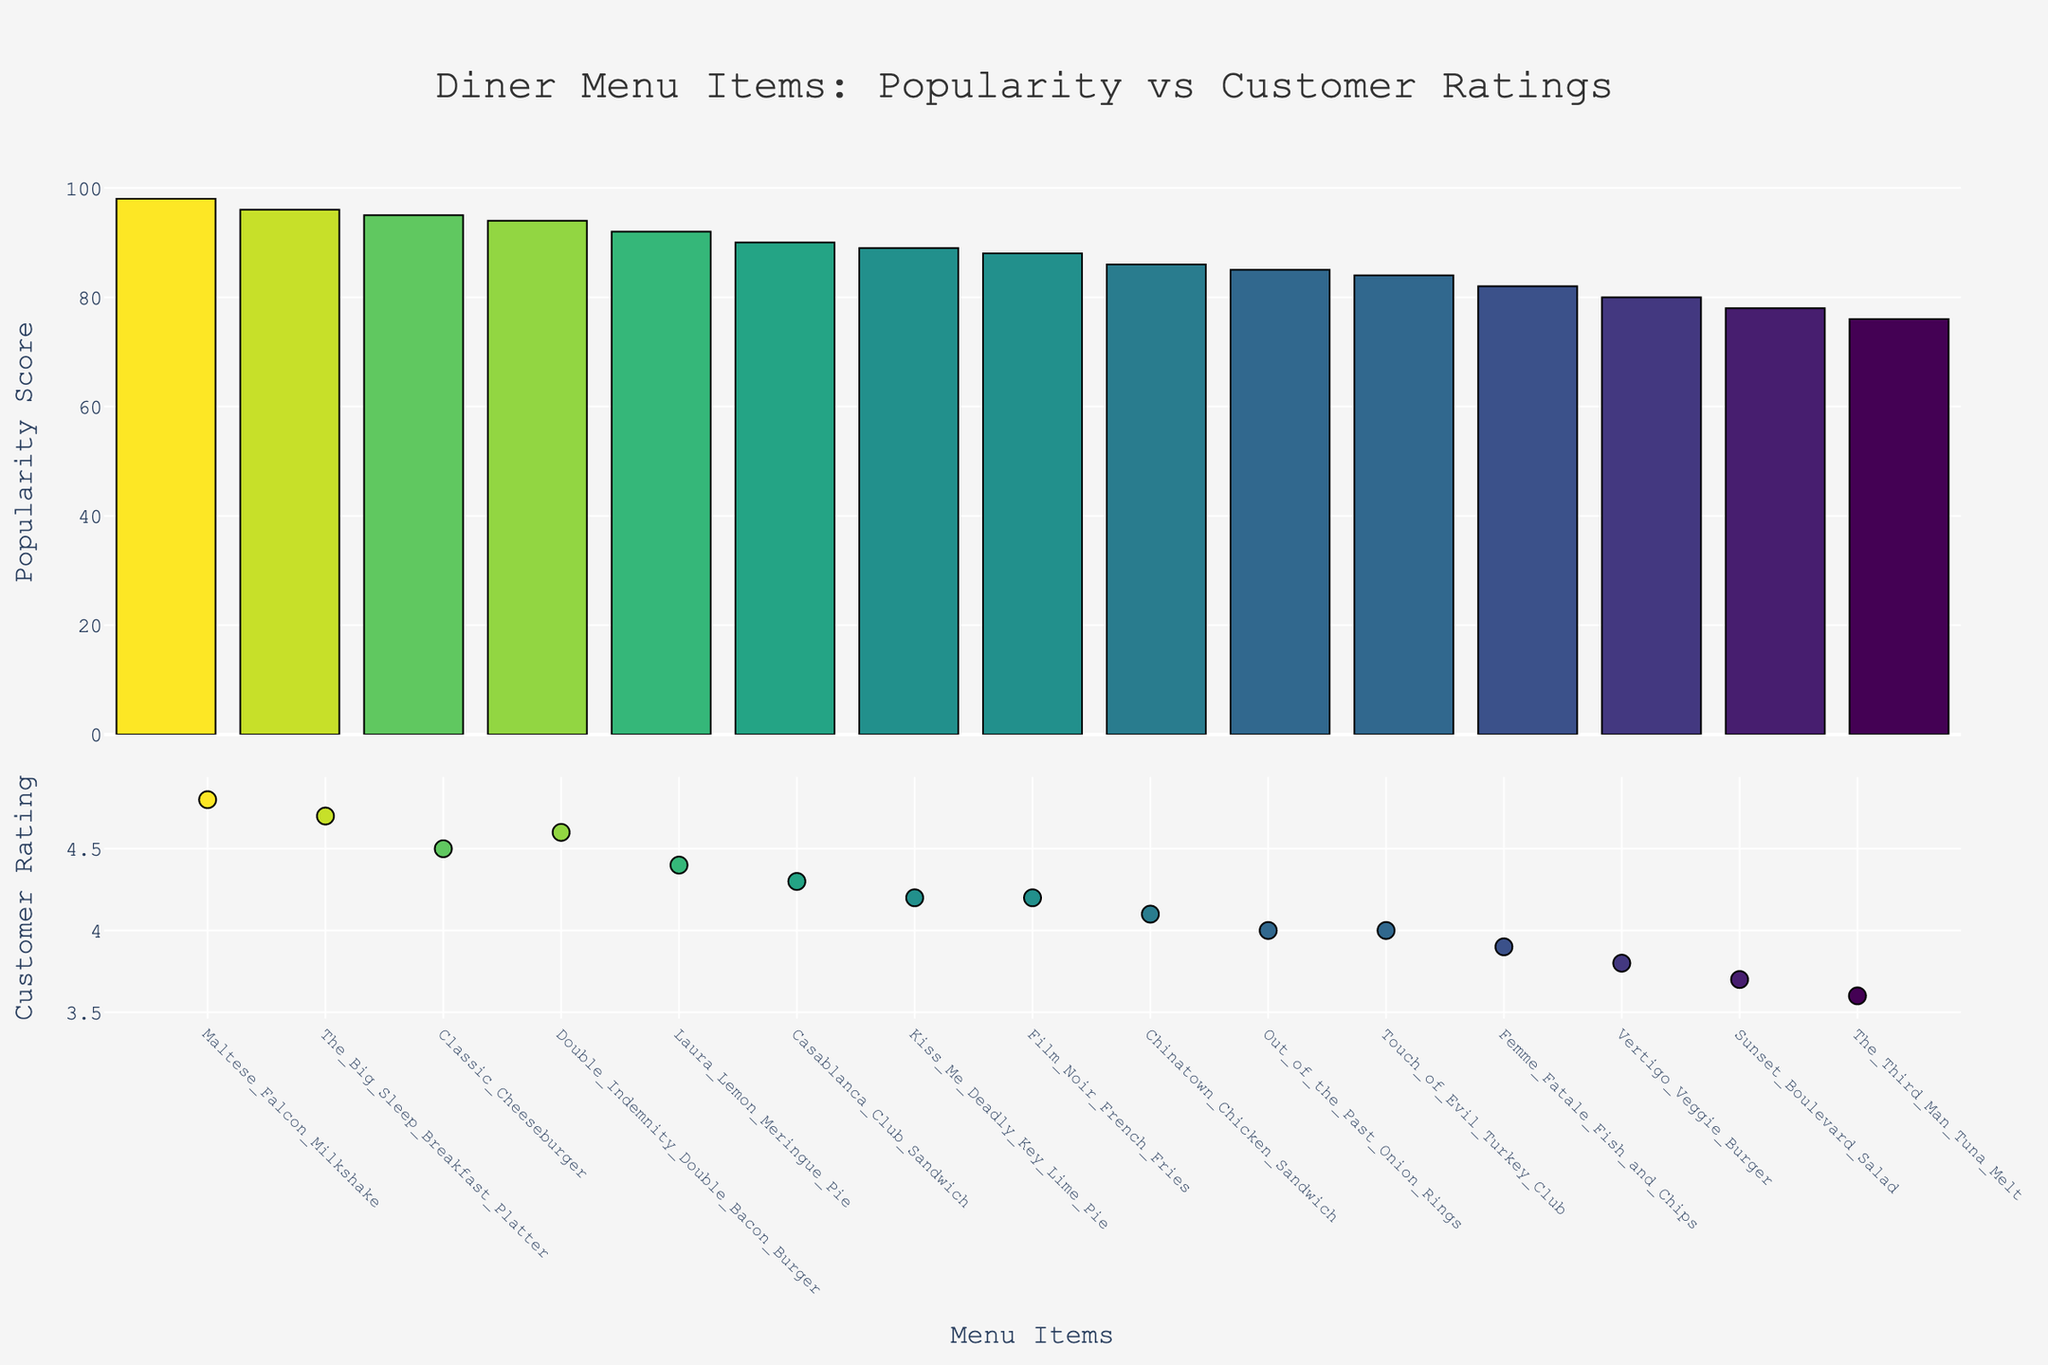How many menu items are displayed in the figure? First, we count the number of menu items in the x-axis of the bar plot. This represents the length of the dataset shown in the plot.
Answer: 15 What is the title of the figure? The title is located at the top of the plot. It is designed to provide a brief overview of what the figure represents.
Answer: "Diner Menu Items: Popularity vs Customer Ratings" Which dish has the highest customer rating? Look at the scatter plot and identify the point that has the highest y-value in the "Customer Rating" dimension. This will correspond to the menu item with the highest rating.
Answer: Maltese Falcon Milkshake Which dish has the lowest popularity score? Look at the bar plot and identify the bar with the lowest height. This will correspond to the menu item with the lowest popularity score.
Answer: The Third Man Tuna Melt Which two dishes have a popularity score above 95? Look at the bar plot and find two bars that extend higher than the 95 mark on the y-axis. Identify the corresponding menu items.
Answer: Maltese Falcon Milkshake, The Big Sleep Breakfast Platter Is there a dish that has both a relatively high customer rating and a low popularity score? Identify if any scatter points representing high ratings are aligned with shorter bars representing low popularity scores. Compare these.
Answer: Touch of Evil Turkey Club Between Femme Fatale Fish and Chips and Out of the Past Onion Rings, which dish is more popular? Compare the heights of the bars for "Femme Fatale Fish and Chips" and "Out of the Past Onion Rings" in the bar plot. The taller bar indicates the more popular dish.
Answer: Out of the Past Onion Rings 